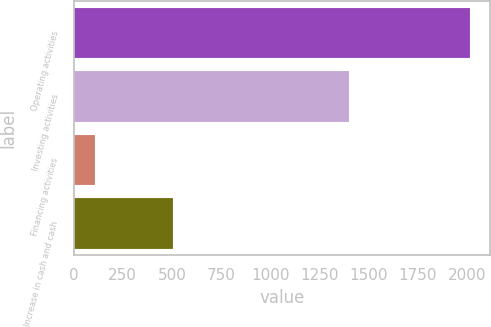Convert chart. <chart><loc_0><loc_0><loc_500><loc_500><bar_chart><fcel>Operating activities<fcel>Investing activities<fcel>Financing activities<fcel>Increase in cash and cash<nl><fcel>2017<fcel>1403<fcel>107<fcel>507<nl></chart> 